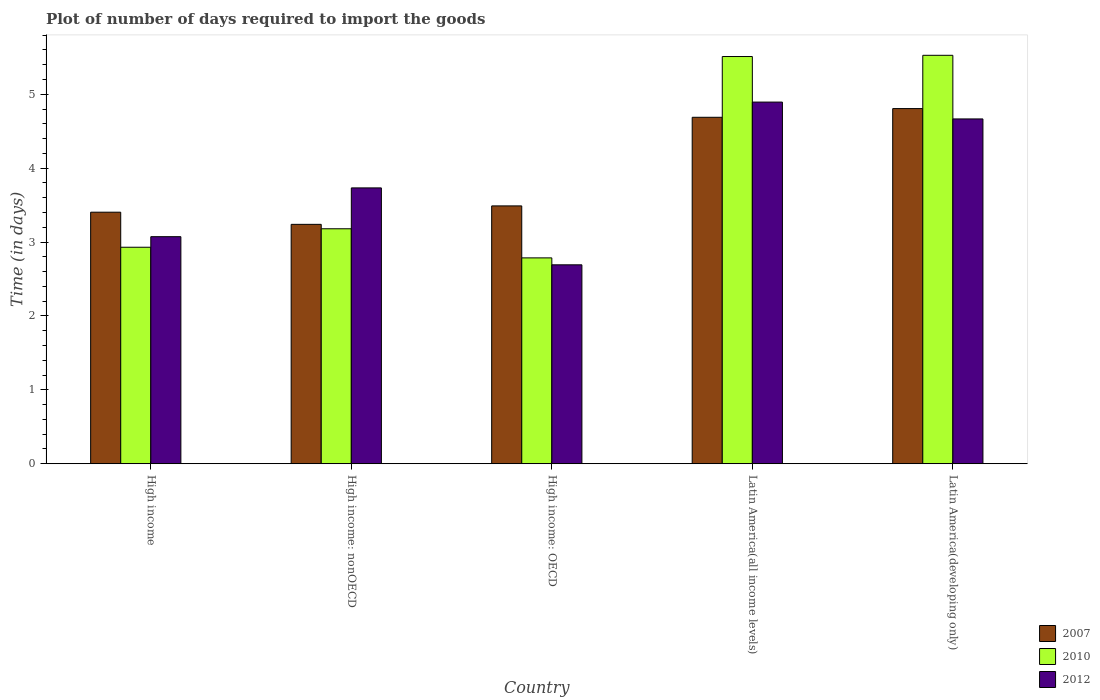How many groups of bars are there?
Your answer should be compact. 5. What is the time required to import goods in 2010 in High income?
Offer a very short reply. 2.93. Across all countries, what is the maximum time required to import goods in 2012?
Keep it short and to the point. 4.89. Across all countries, what is the minimum time required to import goods in 2007?
Make the answer very short. 3.24. In which country was the time required to import goods in 2010 maximum?
Give a very brief answer. Latin America(developing only). In which country was the time required to import goods in 2007 minimum?
Your answer should be compact. High income: nonOECD. What is the total time required to import goods in 2010 in the graph?
Give a very brief answer. 19.94. What is the difference between the time required to import goods in 2007 in Latin America(all income levels) and that in Latin America(developing only)?
Offer a very short reply. -0.12. What is the difference between the time required to import goods in 2007 in Latin America(all income levels) and the time required to import goods in 2010 in High income?
Ensure brevity in your answer.  1.76. What is the average time required to import goods in 2007 per country?
Offer a very short reply. 3.93. What is the difference between the time required to import goods of/in 2010 and time required to import goods of/in 2012 in High income?
Provide a succinct answer. -0.14. In how many countries, is the time required to import goods in 2007 greater than 1.8 days?
Give a very brief answer. 5. What is the ratio of the time required to import goods in 2012 in High income to that in High income: nonOECD?
Ensure brevity in your answer.  0.82. What is the difference between the highest and the second highest time required to import goods in 2012?
Keep it short and to the point. -1.16. What is the difference between the highest and the lowest time required to import goods in 2007?
Ensure brevity in your answer.  1.57. Is the sum of the time required to import goods in 2007 in High income: nonOECD and Latin America(developing only) greater than the maximum time required to import goods in 2012 across all countries?
Offer a terse response. Yes. What does the 1st bar from the left in High income: OECD represents?
Your answer should be compact. 2007. Is it the case that in every country, the sum of the time required to import goods in 2010 and time required to import goods in 2012 is greater than the time required to import goods in 2007?
Ensure brevity in your answer.  Yes. How many bars are there?
Your answer should be compact. 15. Are all the bars in the graph horizontal?
Keep it short and to the point. No. How many countries are there in the graph?
Keep it short and to the point. 5. Are the values on the major ticks of Y-axis written in scientific E-notation?
Keep it short and to the point. No. Does the graph contain any zero values?
Give a very brief answer. No. Does the graph contain grids?
Ensure brevity in your answer.  No. What is the title of the graph?
Keep it short and to the point. Plot of number of days required to import the goods. What is the label or title of the Y-axis?
Make the answer very short. Time (in days). What is the Time (in days) of 2007 in High income?
Give a very brief answer. 3.4. What is the Time (in days) in 2010 in High income?
Keep it short and to the point. 2.93. What is the Time (in days) of 2012 in High income?
Offer a very short reply. 3.07. What is the Time (in days) in 2007 in High income: nonOECD?
Ensure brevity in your answer.  3.24. What is the Time (in days) of 2010 in High income: nonOECD?
Ensure brevity in your answer.  3.18. What is the Time (in days) in 2012 in High income: nonOECD?
Provide a short and direct response. 3.73. What is the Time (in days) in 2007 in High income: OECD?
Your response must be concise. 3.49. What is the Time (in days) of 2010 in High income: OECD?
Your answer should be compact. 2.79. What is the Time (in days) in 2012 in High income: OECD?
Offer a terse response. 2.69. What is the Time (in days) of 2007 in Latin America(all income levels)?
Provide a succinct answer. 4.69. What is the Time (in days) of 2010 in Latin America(all income levels)?
Offer a terse response. 5.51. What is the Time (in days) of 2012 in Latin America(all income levels)?
Offer a terse response. 4.89. What is the Time (in days) in 2007 in Latin America(developing only)?
Offer a terse response. 4.81. What is the Time (in days) in 2010 in Latin America(developing only)?
Ensure brevity in your answer.  5.53. What is the Time (in days) in 2012 in Latin America(developing only)?
Keep it short and to the point. 4.67. Across all countries, what is the maximum Time (in days) in 2007?
Make the answer very short. 4.81. Across all countries, what is the maximum Time (in days) in 2010?
Your answer should be very brief. 5.53. Across all countries, what is the maximum Time (in days) of 2012?
Make the answer very short. 4.89. Across all countries, what is the minimum Time (in days) in 2007?
Your response must be concise. 3.24. Across all countries, what is the minimum Time (in days) of 2010?
Offer a terse response. 2.79. Across all countries, what is the minimum Time (in days) in 2012?
Your response must be concise. 2.69. What is the total Time (in days) in 2007 in the graph?
Provide a succinct answer. 19.63. What is the total Time (in days) of 2010 in the graph?
Your answer should be very brief. 19.94. What is the total Time (in days) of 2012 in the graph?
Give a very brief answer. 19.06. What is the difference between the Time (in days) in 2007 in High income and that in High income: nonOECD?
Provide a short and direct response. 0.16. What is the difference between the Time (in days) of 2010 in High income and that in High income: nonOECD?
Your response must be concise. -0.25. What is the difference between the Time (in days) in 2012 in High income and that in High income: nonOECD?
Your answer should be compact. -0.66. What is the difference between the Time (in days) in 2007 in High income and that in High income: OECD?
Offer a terse response. -0.09. What is the difference between the Time (in days) in 2010 in High income and that in High income: OECD?
Your answer should be very brief. 0.14. What is the difference between the Time (in days) of 2012 in High income and that in High income: OECD?
Provide a short and direct response. 0.38. What is the difference between the Time (in days) in 2007 in High income and that in Latin America(all income levels)?
Ensure brevity in your answer.  -1.28. What is the difference between the Time (in days) of 2010 in High income and that in Latin America(all income levels)?
Keep it short and to the point. -2.58. What is the difference between the Time (in days) of 2012 in High income and that in Latin America(all income levels)?
Provide a short and direct response. -1.82. What is the difference between the Time (in days) of 2007 in High income and that in Latin America(developing only)?
Ensure brevity in your answer.  -1.4. What is the difference between the Time (in days) of 2010 in High income and that in Latin America(developing only)?
Offer a very short reply. -2.6. What is the difference between the Time (in days) of 2012 in High income and that in Latin America(developing only)?
Give a very brief answer. -1.59. What is the difference between the Time (in days) in 2007 in High income: nonOECD and that in High income: OECD?
Provide a succinct answer. -0.25. What is the difference between the Time (in days) in 2010 in High income: nonOECD and that in High income: OECD?
Make the answer very short. 0.39. What is the difference between the Time (in days) of 2012 in High income: nonOECD and that in High income: OECD?
Offer a very short reply. 1.04. What is the difference between the Time (in days) of 2007 in High income: nonOECD and that in Latin America(all income levels)?
Provide a short and direct response. -1.45. What is the difference between the Time (in days) in 2010 in High income: nonOECD and that in Latin America(all income levels)?
Provide a short and direct response. -2.33. What is the difference between the Time (in days) of 2012 in High income: nonOECD and that in Latin America(all income levels)?
Your response must be concise. -1.16. What is the difference between the Time (in days) in 2007 in High income: nonOECD and that in Latin America(developing only)?
Keep it short and to the point. -1.57. What is the difference between the Time (in days) in 2010 in High income: nonOECD and that in Latin America(developing only)?
Offer a terse response. -2.35. What is the difference between the Time (in days) in 2012 in High income: nonOECD and that in Latin America(developing only)?
Provide a short and direct response. -0.93. What is the difference between the Time (in days) in 2007 in High income: OECD and that in Latin America(all income levels)?
Offer a very short reply. -1.2. What is the difference between the Time (in days) in 2010 in High income: OECD and that in Latin America(all income levels)?
Your answer should be very brief. -2.73. What is the difference between the Time (in days) of 2012 in High income: OECD and that in Latin America(all income levels)?
Your response must be concise. -2.2. What is the difference between the Time (in days) in 2007 in High income: OECD and that in Latin America(developing only)?
Make the answer very short. -1.32. What is the difference between the Time (in days) in 2010 in High income: OECD and that in Latin America(developing only)?
Offer a terse response. -2.74. What is the difference between the Time (in days) of 2012 in High income: OECD and that in Latin America(developing only)?
Your response must be concise. -1.97. What is the difference between the Time (in days) of 2007 in Latin America(all income levels) and that in Latin America(developing only)?
Your response must be concise. -0.12. What is the difference between the Time (in days) in 2010 in Latin America(all income levels) and that in Latin America(developing only)?
Provide a succinct answer. -0.02. What is the difference between the Time (in days) of 2012 in Latin America(all income levels) and that in Latin America(developing only)?
Keep it short and to the point. 0.23. What is the difference between the Time (in days) in 2007 in High income and the Time (in days) in 2010 in High income: nonOECD?
Ensure brevity in your answer.  0.22. What is the difference between the Time (in days) in 2007 in High income and the Time (in days) in 2012 in High income: nonOECD?
Offer a terse response. -0.33. What is the difference between the Time (in days) of 2010 in High income and the Time (in days) of 2012 in High income: nonOECD?
Provide a short and direct response. -0.8. What is the difference between the Time (in days) of 2007 in High income and the Time (in days) of 2010 in High income: OECD?
Make the answer very short. 0.62. What is the difference between the Time (in days) in 2007 in High income and the Time (in days) in 2012 in High income: OECD?
Make the answer very short. 0.71. What is the difference between the Time (in days) in 2010 in High income and the Time (in days) in 2012 in High income: OECD?
Make the answer very short. 0.24. What is the difference between the Time (in days) of 2007 in High income and the Time (in days) of 2010 in Latin America(all income levels)?
Your answer should be very brief. -2.11. What is the difference between the Time (in days) of 2007 in High income and the Time (in days) of 2012 in Latin America(all income levels)?
Your answer should be very brief. -1.49. What is the difference between the Time (in days) of 2010 in High income and the Time (in days) of 2012 in Latin America(all income levels)?
Your answer should be compact. -1.96. What is the difference between the Time (in days) of 2007 in High income and the Time (in days) of 2010 in Latin America(developing only)?
Your answer should be compact. -2.12. What is the difference between the Time (in days) of 2007 in High income and the Time (in days) of 2012 in Latin America(developing only)?
Provide a succinct answer. -1.26. What is the difference between the Time (in days) of 2010 in High income and the Time (in days) of 2012 in Latin America(developing only)?
Offer a terse response. -1.74. What is the difference between the Time (in days) in 2007 in High income: nonOECD and the Time (in days) in 2010 in High income: OECD?
Offer a very short reply. 0.45. What is the difference between the Time (in days) in 2007 in High income: nonOECD and the Time (in days) in 2012 in High income: OECD?
Your answer should be compact. 0.55. What is the difference between the Time (in days) in 2010 in High income: nonOECD and the Time (in days) in 2012 in High income: OECD?
Ensure brevity in your answer.  0.49. What is the difference between the Time (in days) of 2007 in High income: nonOECD and the Time (in days) of 2010 in Latin America(all income levels)?
Offer a very short reply. -2.27. What is the difference between the Time (in days) of 2007 in High income: nonOECD and the Time (in days) of 2012 in Latin America(all income levels)?
Make the answer very short. -1.65. What is the difference between the Time (in days) of 2010 in High income: nonOECD and the Time (in days) of 2012 in Latin America(all income levels)?
Make the answer very short. -1.71. What is the difference between the Time (in days) of 2007 in High income: nonOECD and the Time (in days) of 2010 in Latin America(developing only)?
Ensure brevity in your answer.  -2.29. What is the difference between the Time (in days) in 2007 in High income: nonOECD and the Time (in days) in 2012 in Latin America(developing only)?
Offer a very short reply. -1.43. What is the difference between the Time (in days) of 2010 in High income: nonOECD and the Time (in days) of 2012 in Latin America(developing only)?
Make the answer very short. -1.49. What is the difference between the Time (in days) in 2007 in High income: OECD and the Time (in days) in 2010 in Latin America(all income levels)?
Offer a terse response. -2.02. What is the difference between the Time (in days) of 2007 in High income: OECD and the Time (in days) of 2012 in Latin America(all income levels)?
Offer a terse response. -1.41. What is the difference between the Time (in days) of 2010 in High income: OECD and the Time (in days) of 2012 in Latin America(all income levels)?
Provide a succinct answer. -2.11. What is the difference between the Time (in days) in 2007 in High income: OECD and the Time (in days) in 2010 in Latin America(developing only)?
Provide a succinct answer. -2.04. What is the difference between the Time (in days) in 2007 in High income: OECD and the Time (in days) in 2012 in Latin America(developing only)?
Give a very brief answer. -1.18. What is the difference between the Time (in days) of 2010 in High income: OECD and the Time (in days) of 2012 in Latin America(developing only)?
Ensure brevity in your answer.  -1.88. What is the difference between the Time (in days) in 2007 in Latin America(all income levels) and the Time (in days) in 2010 in Latin America(developing only)?
Your answer should be compact. -0.84. What is the difference between the Time (in days) in 2007 in Latin America(all income levels) and the Time (in days) in 2012 in Latin America(developing only)?
Your answer should be compact. 0.02. What is the difference between the Time (in days) in 2010 in Latin America(all income levels) and the Time (in days) in 2012 in Latin America(developing only)?
Ensure brevity in your answer.  0.84. What is the average Time (in days) of 2007 per country?
Provide a short and direct response. 3.93. What is the average Time (in days) of 2010 per country?
Keep it short and to the point. 3.99. What is the average Time (in days) in 2012 per country?
Offer a very short reply. 3.81. What is the difference between the Time (in days) of 2007 and Time (in days) of 2010 in High income?
Offer a terse response. 0.47. What is the difference between the Time (in days) in 2007 and Time (in days) in 2012 in High income?
Ensure brevity in your answer.  0.33. What is the difference between the Time (in days) in 2010 and Time (in days) in 2012 in High income?
Your answer should be very brief. -0.14. What is the difference between the Time (in days) of 2007 and Time (in days) of 2010 in High income: nonOECD?
Provide a succinct answer. 0.06. What is the difference between the Time (in days) of 2007 and Time (in days) of 2012 in High income: nonOECD?
Ensure brevity in your answer.  -0.49. What is the difference between the Time (in days) in 2010 and Time (in days) in 2012 in High income: nonOECD?
Your response must be concise. -0.55. What is the difference between the Time (in days) of 2007 and Time (in days) of 2010 in High income: OECD?
Your answer should be very brief. 0.7. What is the difference between the Time (in days) in 2007 and Time (in days) in 2012 in High income: OECD?
Give a very brief answer. 0.8. What is the difference between the Time (in days) in 2010 and Time (in days) in 2012 in High income: OECD?
Offer a very short reply. 0.09. What is the difference between the Time (in days) in 2007 and Time (in days) in 2010 in Latin America(all income levels)?
Offer a very short reply. -0.82. What is the difference between the Time (in days) of 2007 and Time (in days) of 2012 in Latin America(all income levels)?
Provide a succinct answer. -0.21. What is the difference between the Time (in days) in 2010 and Time (in days) in 2012 in Latin America(all income levels)?
Your answer should be compact. 0.62. What is the difference between the Time (in days) in 2007 and Time (in days) in 2010 in Latin America(developing only)?
Provide a succinct answer. -0.72. What is the difference between the Time (in days) of 2007 and Time (in days) of 2012 in Latin America(developing only)?
Provide a succinct answer. 0.14. What is the difference between the Time (in days) in 2010 and Time (in days) in 2012 in Latin America(developing only)?
Your answer should be very brief. 0.86. What is the ratio of the Time (in days) in 2007 in High income to that in High income: nonOECD?
Your answer should be compact. 1.05. What is the ratio of the Time (in days) of 2010 in High income to that in High income: nonOECD?
Offer a terse response. 0.92. What is the ratio of the Time (in days) of 2012 in High income to that in High income: nonOECD?
Provide a succinct answer. 0.82. What is the ratio of the Time (in days) in 2007 in High income to that in High income: OECD?
Your answer should be very brief. 0.98. What is the ratio of the Time (in days) in 2010 in High income to that in High income: OECD?
Your answer should be very brief. 1.05. What is the ratio of the Time (in days) in 2012 in High income to that in High income: OECD?
Your answer should be compact. 1.14. What is the ratio of the Time (in days) in 2007 in High income to that in Latin America(all income levels)?
Make the answer very short. 0.73. What is the ratio of the Time (in days) in 2010 in High income to that in Latin America(all income levels)?
Provide a short and direct response. 0.53. What is the ratio of the Time (in days) of 2012 in High income to that in Latin America(all income levels)?
Your response must be concise. 0.63. What is the ratio of the Time (in days) in 2007 in High income to that in Latin America(developing only)?
Ensure brevity in your answer.  0.71. What is the ratio of the Time (in days) of 2010 in High income to that in Latin America(developing only)?
Your answer should be very brief. 0.53. What is the ratio of the Time (in days) in 2012 in High income to that in Latin America(developing only)?
Your response must be concise. 0.66. What is the ratio of the Time (in days) of 2007 in High income: nonOECD to that in High income: OECD?
Make the answer very short. 0.93. What is the ratio of the Time (in days) of 2010 in High income: nonOECD to that in High income: OECD?
Make the answer very short. 1.14. What is the ratio of the Time (in days) of 2012 in High income: nonOECD to that in High income: OECD?
Your answer should be compact. 1.39. What is the ratio of the Time (in days) in 2007 in High income: nonOECD to that in Latin America(all income levels)?
Offer a very short reply. 0.69. What is the ratio of the Time (in days) of 2010 in High income: nonOECD to that in Latin America(all income levels)?
Your answer should be very brief. 0.58. What is the ratio of the Time (in days) in 2012 in High income: nonOECD to that in Latin America(all income levels)?
Provide a succinct answer. 0.76. What is the ratio of the Time (in days) in 2007 in High income: nonOECD to that in Latin America(developing only)?
Your response must be concise. 0.67. What is the ratio of the Time (in days) of 2010 in High income: nonOECD to that in Latin America(developing only)?
Provide a succinct answer. 0.58. What is the ratio of the Time (in days) in 2007 in High income: OECD to that in Latin America(all income levels)?
Your answer should be very brief. 0.74. What is the ratio of the Time (in days) of 2010 in High income: OECD to that in Latin America(all income levels)?
Offer a terse response. 0.51. What is the ratio of the Time (in days) in 2012 in High income: OECD to that in Latin America(all income levels)?
Ensure brevity in your answer.  0.55. What is the ratio of the Time (in days) in 2007 in High income: OECD to that in Latin America(developing only)?
Your response must be concise. 0.73. What is the ratio of the Time (in days) of 2010 in High income: OECD to that in Latin America(developing only)?
Provide a short and direct response. 0.5. What is the ratio of the Time (in days) in 2012 in High income: OECD to that in Latin America(developing only)?
Provide a succinct answer. 0.58. What is the ratio of the Time (in days) in 2007 in Latin America(all income levels) to that in Latin America(developing only)?
Your answer should be compact. 0.98. What is the ratio of the Time (in days) in 2012 in Latin America(all income levels) to that in Latin America(developing only)?
Your response must be concise. 1.05. What is the difference between the highest and the second highest Time (in days) in 2007?
Offer a terse response. 0.12. What is the difference between the highest and the second highest Time (in days) of 2010?
Ensure brevity in your answer.  0.02. What is the difference between the highest and the second highest Time (in days) in 2012?
Make the answer very short. 0.23. What is the difference between the highest and the lowest Time (in days) in 2007?
Your response must be concise. 1.57. What is the difference between the highest and the lowest Time (in days) of 2010?
Your answer should be compact. 2.74. What is the difference between the highest and the lowest Time (in days) of 2012?
Offer a terse response. 2.2. 